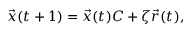Convert formula to latex. <formula><loc_0><loc_0><loc_500><loc_500>\begin{array} { r } { \vec { x } ( t + 1 ) = \vec { x } ( t ) C + \zeta \vec { r } ( t ) , } \end{array}</formula> 